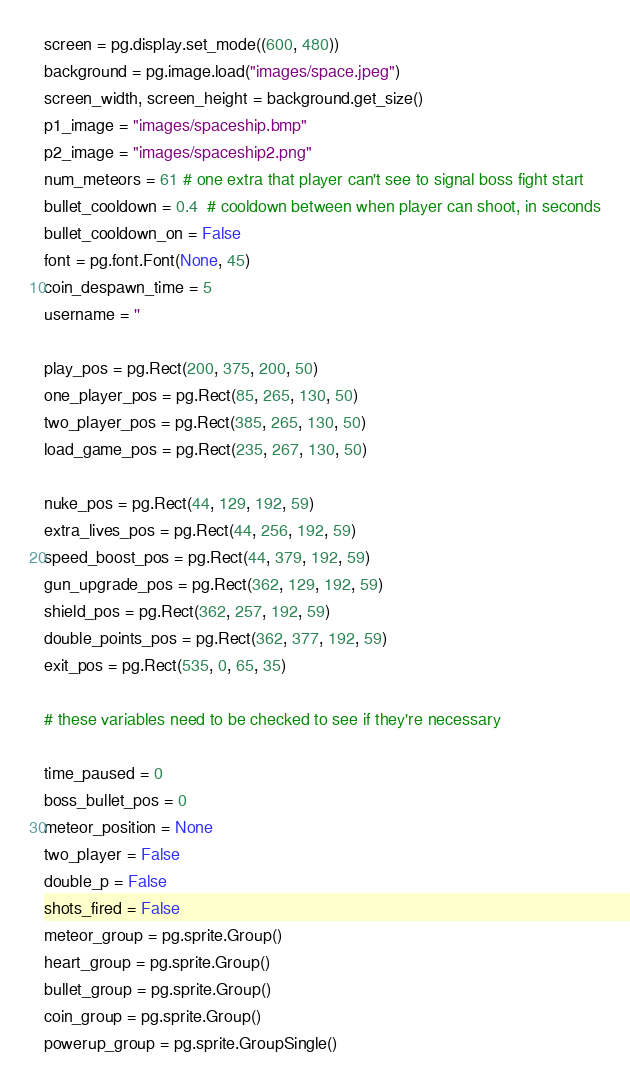Convert code to text. <code><loc_0><loc_0><loc_500><loc_500><_Python_>
screen = pg.display.set_mode((600, 480))
background = pg.image.load("images/space.jpeg")
screen_width, screen_height = background.get_size()
p1_image = "images/spaceship.bmp"
p2_image = "images/spaceship2.png"
num_meteors = 61 # one extra that player can't see to signal boss fight start
bullet_cooldown = 0.4  # cooldown between when player can shoot, in seconds
bullet_cooldown_on = False
font = pg.font.Font(None, 45)
coin_despawn_time = 5
username = ''

play_pos = pg.Rect(200, 375, 200, 50)
one_player_pos = pg.Rect(85, 265, 130, 50)
two_player_pos = pg.Rect(385, 265, 130, 50)
load_game_pos = pg.Rect(235, 267, 130, 50)

nuke_pos = pg.Rect(44, 129, 192, 59)
extra_lives_pos = pg.Rect(44, 256, 192, 59)
speed_boost_pos = pg.Rect(44, 379, 192, 59)
gun_upgrade_pos = pg.Rect(362, 129, 192, 59)
shield_pos = pg.Rect(362, 257, 192, 59)
double_points_pos = pg.Rect(362, 377, 192, 59)
exit_pos = pg.Rect(535, 0, 65, 35)

# these variables need to be checked to see if they're necessary

time_paused = 0
boss_bullet_pos = 0
meteor_position = None
two_player = False
double_p = False
shots_fired = False
meteor_group = pg.sprite.Group()
heart_group = pg.sprite.Group()
bullet_group = pg.sprite.Group()
coin_group = pg.sprite.Group()
powerup_group = pg.sprite.GroupSingle()
</code> 